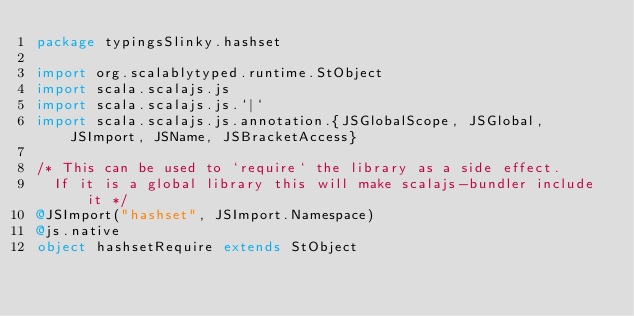Convert code to text. <code><loc_0><loc_0><loc_500><loc_500><_Scala_>package typingsSlinky.hashset

import org.scalablytyped.runtime.StObject
import scala.scalajs.js
import scala.scalajs.js.`|`
import scala.scalajs.js.annotation.{JSGlobalScope, JSGlobal, JSImport, JSName, JSBracketAccess}

/* This can be used to `require` the library as a side effect.
  If it is a global library this will make scalajs-bundler include it */
@JSImport("hashset", JSImport.Namespace)
@js.native
object hashsetRequire extends StObject
</code> 